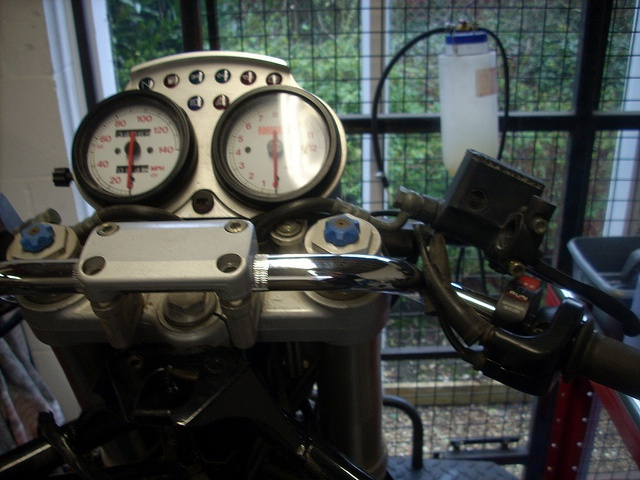Describe the objects in this image and their specific colors. I can see a motorcycle in black, darkgray, and gray tones in this image. 